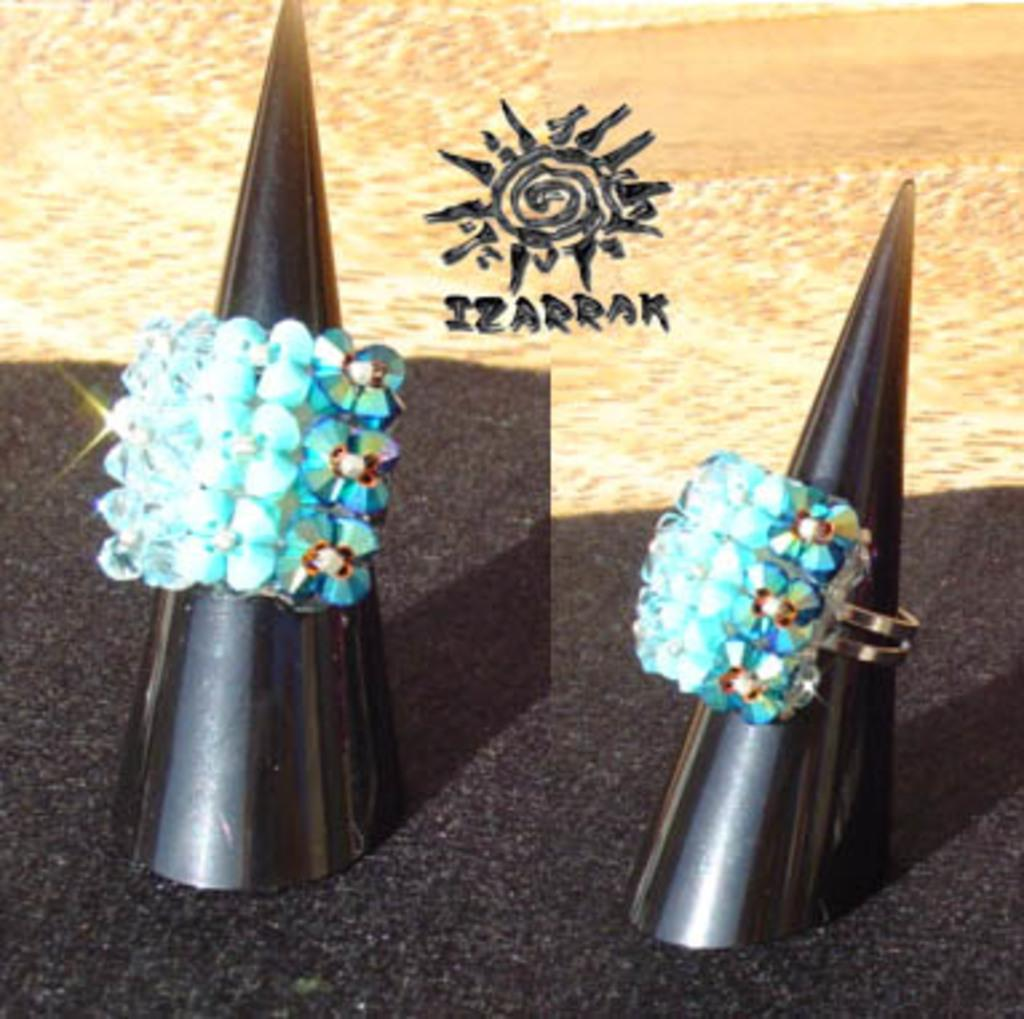What is the composition of the image? The image is a collage containing two pictures. What objects are featured in the pictures? There are rings in the pictures. How are the rings positioned in the pictures? The rings are placed on a stand. What can be seen in the background of the pictures? There is a wooden wall and a logo in the background of the pictures. What type of corn can be seen growing on the wooden wall in the image? There is no corn present in the image; the wooden wall is a background element without any plants or crops. 